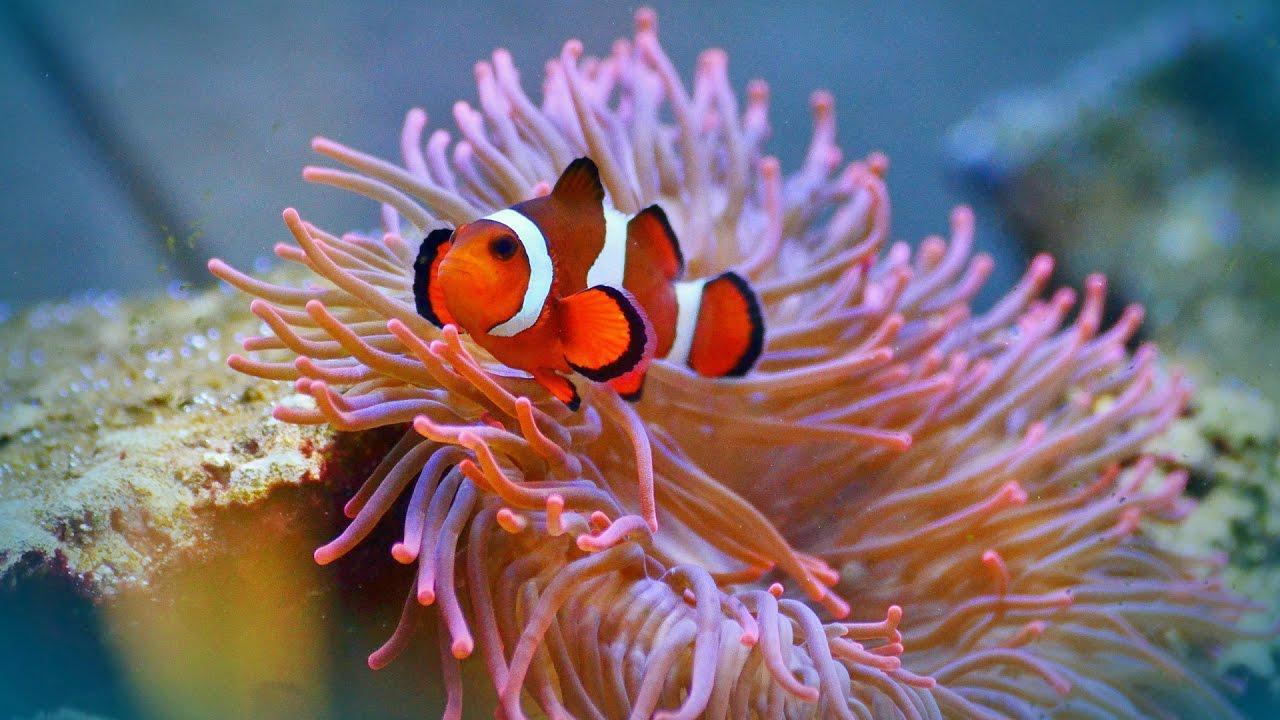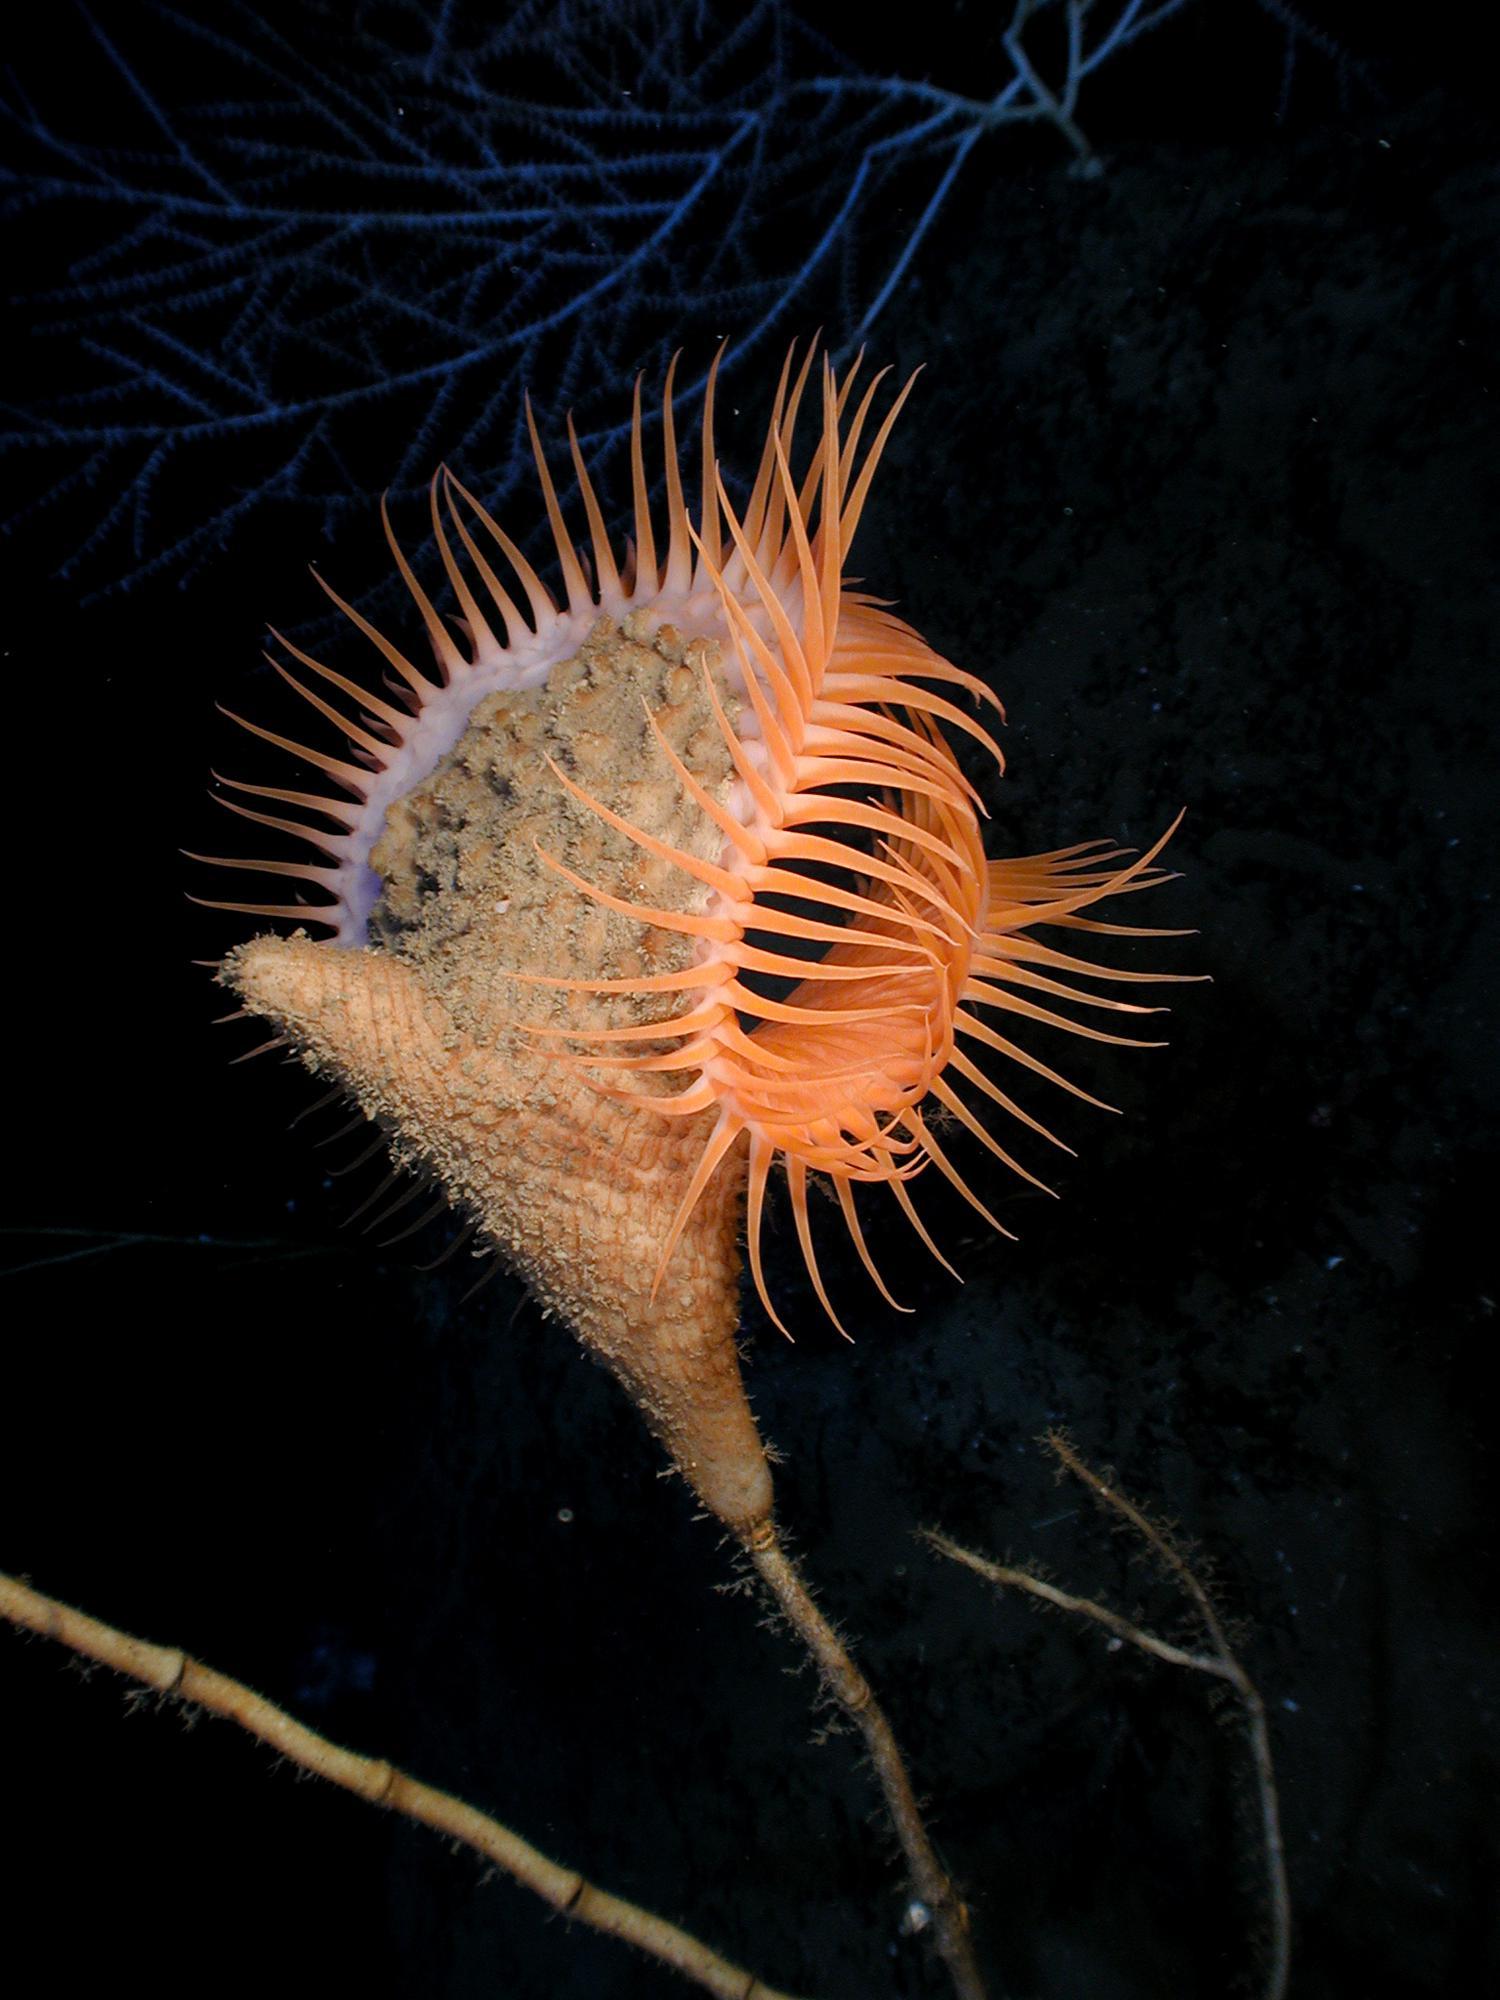The first image is the image on the left, the second image is the image on the right. Considering the images on both sides, is "A flower-shaped anemone has solid-colored, tapered, pinkish-lavender tendrils, with no fish swimming among them." valid? Answer yes or no. No. 